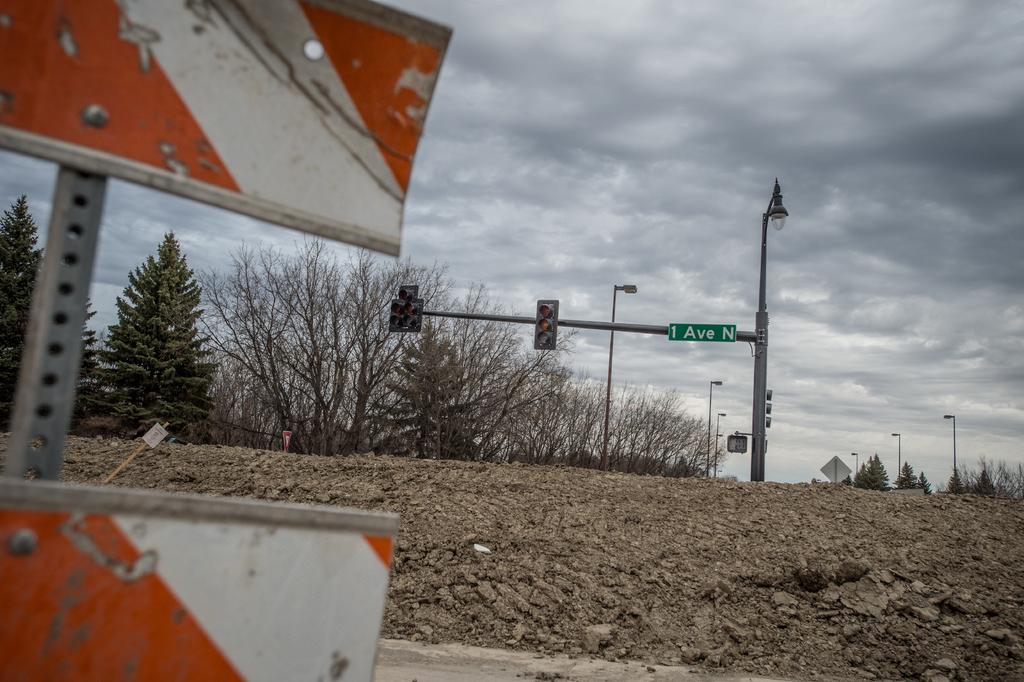What is the name of the street shown?
Keep it short and to the point. 1 ave n. 